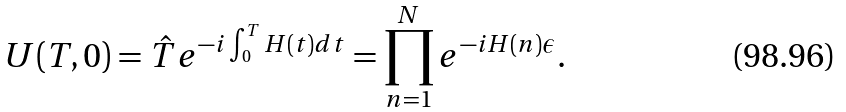<formula> <loc_0><loc_0><loc_500><loc_500>U ( T , 0 ) = \hat { T } e ^ { - i \int _ { 0 } ^ { T } H ( t ) d t } = \prod _ { n = 1 } ^ { N } e ^ { - i H ( n ) \epsilon } .</formula> 